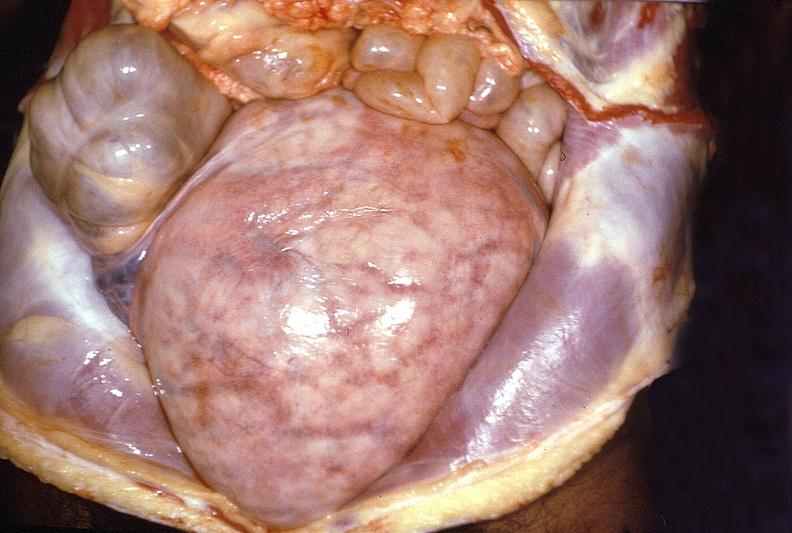where does this part belong to?
Answer the question using a single word or phrase. Female reproductive system 